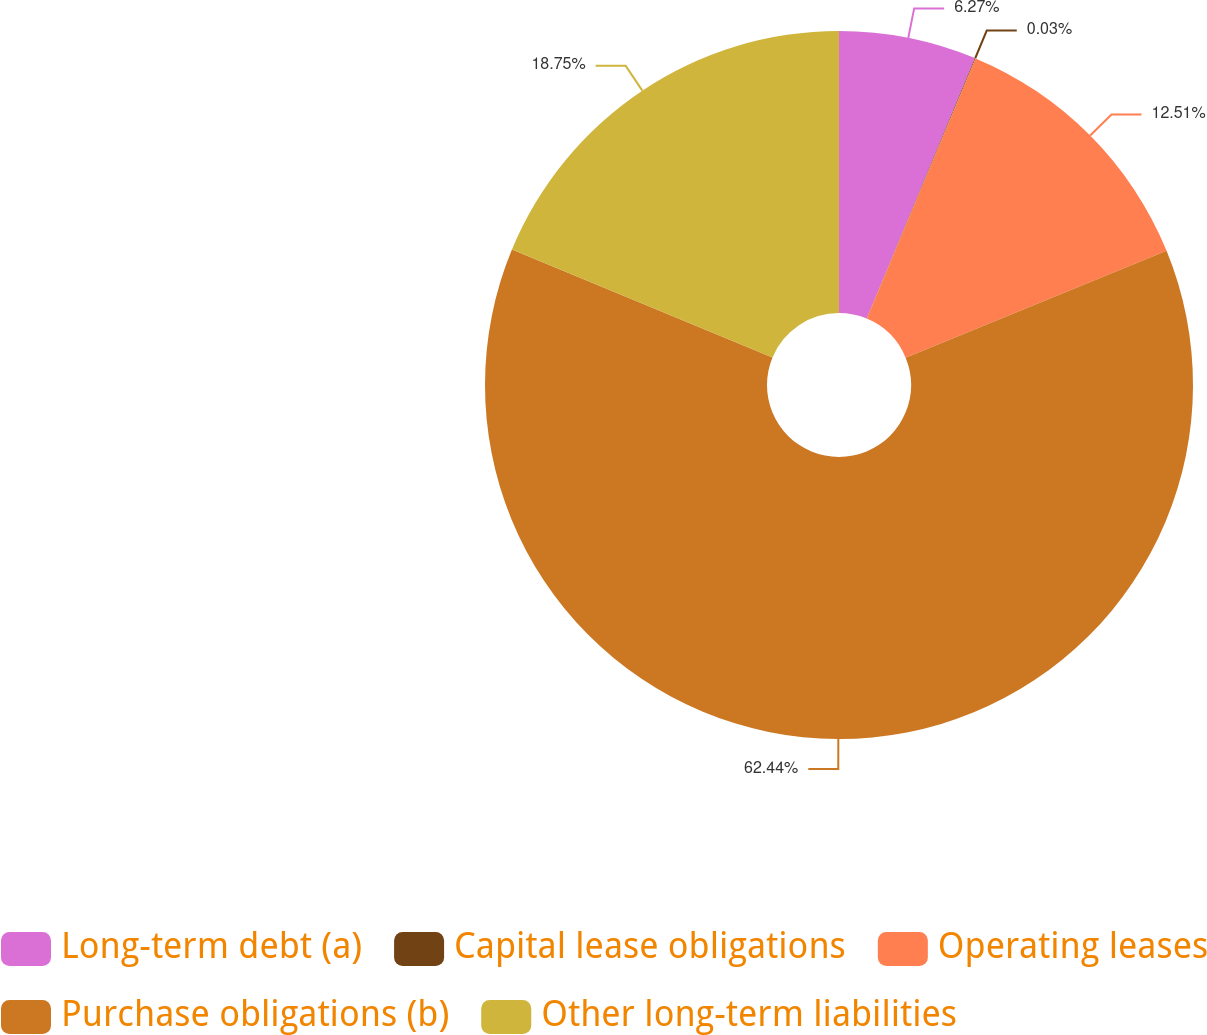Convert chart to OTSL. <chart><loc_0><loc_0><loc_500><loc_500><pie_chart><fcel>Long-term debt (a)<fcel>Capital lease obligations<fcel>Operating leases<fcel>Purchase obligations (b)<fcel>Other long-term liabilities<nl><fcel>6.27%<fcel>0.03%<fcel>12.51%<fcel>62.43%<fcel>18.75%<nl></chart> 